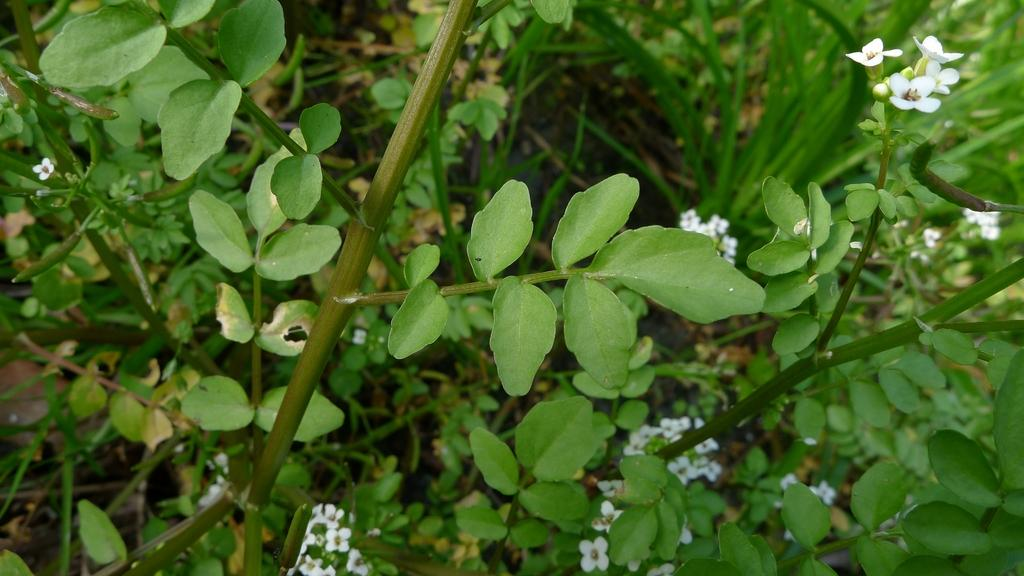What type of vegetation can be seen in the image? There is grass and flowering plants in the image. Where was the image taken? The image was taken in a farm. What type of bun is being sold on the street in the image? There is no street or bun present in the image; it features grass, flowering plants, and is taken in a farm setting. 